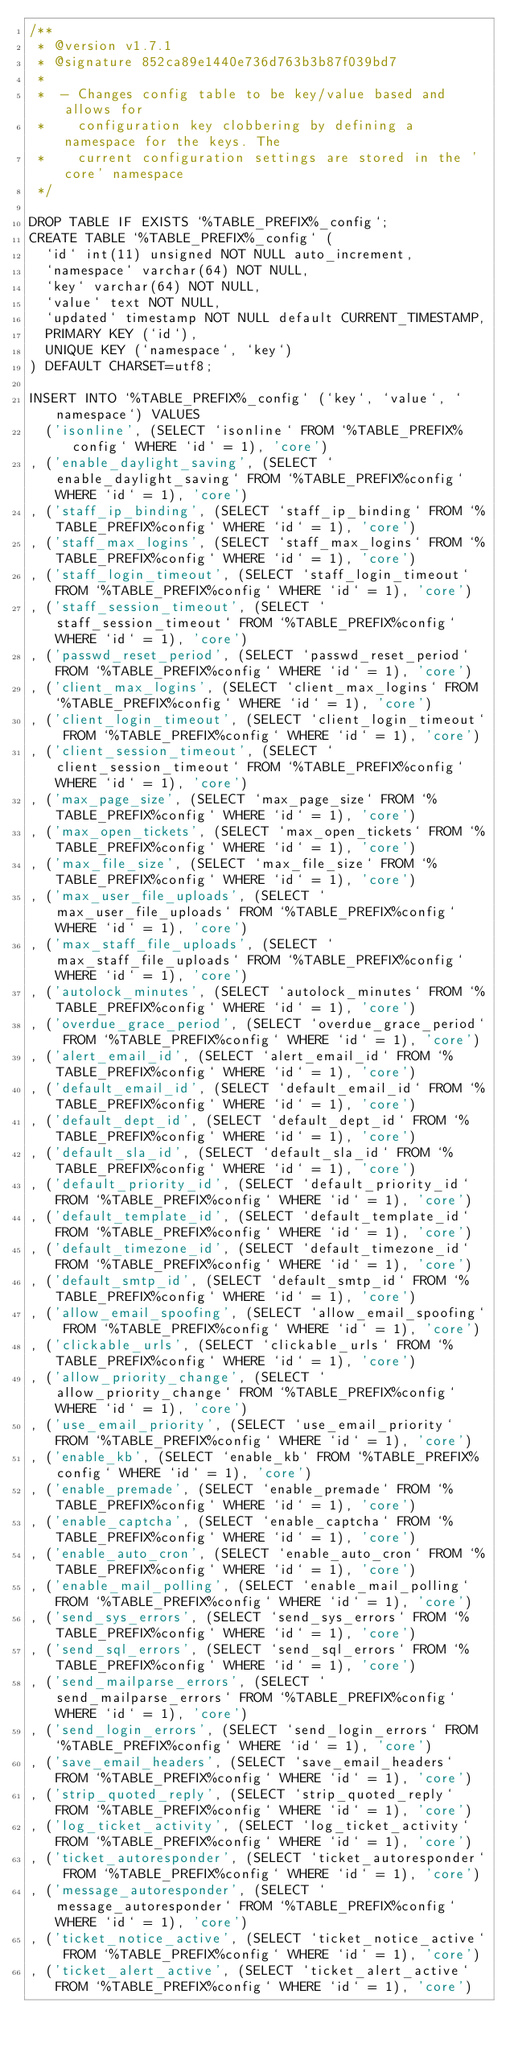<code> <loc_0><loc_0><loc_500><loc_500><_SQL_>/**
 * @version v1.7.1
 * @signature 852ca89e1440e736d763b3b87f039bd7
 *
 *  - Changes config table to be key/value based and allows for
 *    configuration key clobbering by defining a namespace for the keys. The
 *    current configuration settings are stored in the 'core' namespace
 */

DROP TABLE IF EXISTS `%TABLE_PREFIX%_config`;
CREATE TABLE `%TABLE_PREFIX%_config` (
  `id` int(11) unsigned NOT NULL auto_increment,
  `namespace` varchar(64) NOT NULL,
  `key` varchar(64) NOT NULL,
  `value` text NOT NULL,
  `updated` timestamp NOT NULL default CURRENT_TIMESTAMP,
  PRIMARY KEY (`id`),
  UNIQUE KEY (`namespace`, `key`)
) DEFAULT CHARSET=utf8;

INSERT INTO `%TABLE_PREFIX%_config` (`key`, `value`, `namespace`) VALUES
  ('isonline', (SELECT `isonline` FROM `%TABLE_PREFIX%config` WHERE `id` = 1), 'core')
, ('enable_daylight_saving', (SELECT `enable_daylight_saving` FROM `%TABLE_PREFIX%config` WHERE `id` = 1), 'core')
, ('staff_ip_binding', (SELECT `staff_ip_binding` FROM `%TABLE_PREFIX%config` WHERE `id` = 1), 'core')
, ('staff_max_logins', (SELECT `staff_max_logins` FROM `%TABLE_PREFIX%config` WHERE `id` = 1), 'core')
, ('staff_login_timeout', (SELECT `staff_login_timeout` FROM `%TABLE_PREFIX%config` WHERE `id` = 1), 'core')
, ('staff_session_timeout', (SELECT `staff_session_timeout` FROM `%TABLE_PREFIX%config` WHERE `id` = 1), 'core')
, ('passwd_reset_period', (SELECT `passwd_reset_period` FROM `%TABLE_PREFIX%config` WHERE `id` = 1), 'core')
, ('client_max_logins', (SELECT `client_max_logins` FROM `%TABLE_PREFIX%config` WHERE `id` = 1), 'core')
, ('client_login_timeout', (SELECT `client_login_timeout` FROM `%TABLE_PREFIX%config` WHERE `id` = 1), 'core')
, ('client_session_timeout', (SELECT `client_session_timeout` FROM `%TABLE_PREFIX%config` WHERE `id` = 1), 'core')
, ('max_page_size', (SELECT `max_page_size` FROM `%TABLE_PREFIX%config` WHERE `id` = 1), 'core')
, ('max_open_tickets', (SELECT `max_open_tickets` FROM `%TABLE_PREFIX%config` WHERE `id` = 1), 'core')
, ('max_file_size', (SELECT `max_file_size` FROM `%TABLE_PREFIX%config` WHERE `id` = 1), 'core')
, ('max_user_file_uploads', (SELECT `max_user_file_uploads` FROM `%TABLE_PREFIX%config` WHERE `id` = 1), 'core')
, ('max_staff_file_uploads', (SELECT `max_staff_file_uploads` FROM `%TABLE_PREFIX%config` WHERE `id` = 1), 'core')
, ('autolock_minutes', (SELECT `autolock_minutes` FROM `%TABLE_PREFIX%config` WHERE `id` = 1), 'core')
, ('overdue_grace_period', (SELECT `overdue_grace_period` FROM `%TABLE_PREFIX%config` WHERE `id` = 1), 'core')
, ('alert_email_id', (SELECT `alert_email_id` FROM `%TABLE_PREFIX%config` WHERE `id` = 1), 'core')
, ('default_email_id', (SELECT `default_email_id` FROM `%TABLE_PREFIX%config` WHERE `id` = 1), 'core')
, ('default_dept_id', (SELECT `default_dept_id` FROM `%TABLE_PREFIX%config` WHERE `id` = 1), 'core')
, ('default_sla_id', (SELECT `default_sla_id` FROM `%TABLE_PREFIX%config` WHERE `id` = 1), 'core')
, ('default_priority_id', (SELECT `default_priority_id` FROM `%TABLE_PREFIX%config` WHERE `id` = 1), 'core')
, ('default_template_id', (SELECT `default_template_id` FROM `%TABLE_PREFIX%config` WHERE `id` = 1), 'core')
, ('default_timezone_id', (SELECT `default_timezone_id` FROM `%TABLE_PREFIX%config` WHERE `id` = 1), 'core')
, ('default_smtp_id', (SELECT `default_smtp_id` FROM `%TABLE_PREFIX%config` WHERE `id` = 1), 'core')
, ('allow_email_spoofing', (SELECT `allow_email_spoofing` FROM `%TABLE_PREFIX%config` WHERE `id` = 1), 'core')
, ('clickable_urls', (SELECT `clickable_urls` FROM `%TABLE_PREFIX%config` WHERE `id` = 1), 'core')
, ('allow_priority_change', (SELECT `allow_priority_change` FROM `%TABLE_PREFIX%config` WHERE `id` = 1), 'core')
, ('use_email_priority', (SELECT `use_email_priority` FROM `%TABLE_PREFIX%config` WHERE `id` = 1), 'core')
, ('enable_kb', (SELECT `enable_kb` FROM `%TABLE_PREFIX%config` WHERE `id` = 1), 'core')
, ('enable_premade', (SELECT `enable_premade` FROM `%TABLE_PREFIX%config` WHERE `id` = 1), 'core')
, ('enable_captcha', (SELECT `enable_captcha` FROM `%TABLE_PREFIX%config` WHERE `id` = 1), 'core')
, ('enable_auto_cron', (SELECT `enable_auto_cron` FROM `%TABLE_PREFIX%config` WHERE `id` = 1), 'core')
, ('enable_mail_polling', (SELECT `enable_mail_polling` FROM `%TABLE_PREFIX%config` WHERE `id` = 1), 'core')
, ('send_sys_errors', (SELECT `send_sys_errors` FROM `%TABLE_PREFIX%config` WHERE `id` = 1), 'core')
, ('send_sql_errors', (SELECT `send_sql_errors` FROM `%TABLE_PREFIX%config` WHERE `id` = 1), 'core')
, ('send_mailparse_errors', (SELECT `send_mailparse_errors` FROM `%TABLE_PREFIX%config` WHERE `id` = 1), 'core')
, ('send_login_errors', (SELECT `send_login_errors` FROM `%TABLE_PREFIX%config` WHERE `id` = 1), 'core')
, ('save_email_headers', (SELECT `save_email_headers` FROM `%TABLE_PREFIX%config` WHERE `id` = 1), 'core')
, ('strip_quoted_reply', (SELECT `strip_quoted_reply` FROM `%TABLE_PREFIX%config` WHERE `id` = 1), 'core')
, ('log_ticket_activity', (SELECT `log_ticket_activity` FROM `%TABLE_PREFIX%config` WHERE `id` = 1), 'core')
, ('ticket_autoresponder', (SELECT `ticket_autoresponder` FROM `%TABLE_PREFIX%config` WHERE `id` = 1), 'core')
, ('message_autoresponder', (SELECT `message_autoresponder` FROM `%TABLE_PREFIX%config` WHERE `id` = 1), 'core')
, ('ticket_notice_active', (SELECT `ticket_notice_active` FROM `%TABLE_PREFIX%config` WHERE `id` = 1), 'core')
, ('ticket_alert_active', (SELECT `ticket_alert_active` FROM `%TABLE_PREFIX%config` WHERE `id` = 1), 'core')</code> 